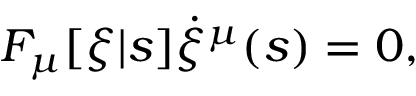Convert formula to latex. <formula><loc_0><loc_0><loc_500><loc_500>F _ { \mu } [ \xi | s ] \dot { \xi } ^ { \mu } ( s ) = 0 ,</formula> 